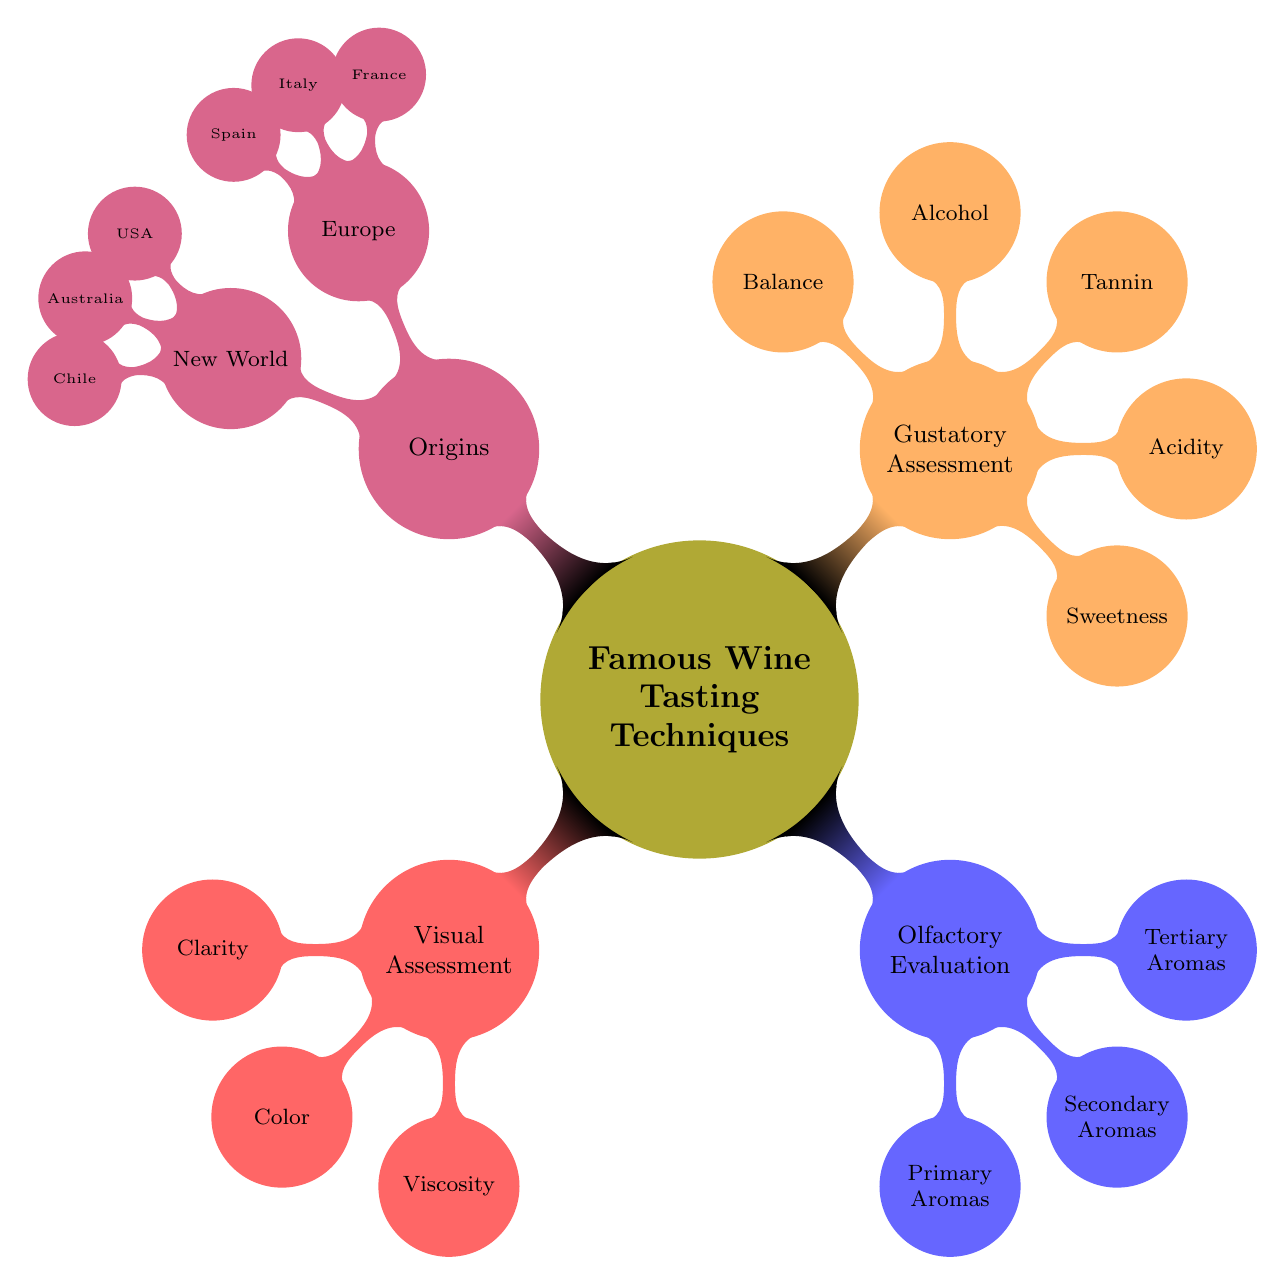What are the three main wine tasting techniques? The diagram identifies three primary wine tasting techniques: Visual Assessment, Olfactory Evaluation, and Gustatory Assessment. These are the main categories of wine tasting methods presented in the mind map.
Answer: Visual Assessment, Olfactory Evaluation, Gustatory Assessment How many aspects are included in Gustatory Assessment? The diagram lists five components under Gustatory Assessment: Sweetness, Acidity, Tannin, Alcohol, and Balance. Counting these elements provides the answer to the question regarding how many aspects are included.
Answer: 5 What types of aromas are included in Olfactory Evaluation? The Olfactory Evaluation section of the diagram specifies three types of aromas: Primary Aromas, Secondary Aromas, and Tertiary Aromas. By identifying these distinct categories, we can provide the answer.
Answer: Primary Aromas, Secondary Aromas, Tertiary Aromas Which country in Europe is associated with Bordeaux wine tasting techniques? The diagram lists France as one of the countries under the Origins in Europe section and specifically associates it with Bordeaux, indicating that France is known for this technique.
Answer: France What is the main focus of Visual Assessment? Visual Assessment focuses on three elements: Clarity, Color, and Viscosity. These aspects are essential for the visual evaluation of wine, helping tasters understand different properties visible in the wine.
Answer: Clarity, Color, Viscosity Which wine tasting technique relates to the relationship between acidity and freshness? The diagram shows that Acidity in the Gustatory Assessment section is specifically mentioned to contribute to the wine's freshness, highlighting the connection between these two concepts.
Answer: Acidity What is the primary aroma derived from light white wines? The diagram notes that Floral Aromas come from light white wines like Riesling, providing a direct answer regarding the specific aroma type associated with these wines.
Answer: Floral Aromas Which New World country is known for Shiraz tasting methods? According to the diagram, Australia is listed under New World, specifically mentioning Shiraz as a technique associated with its wine tasting practices. Therefore, Australia is the correct answer.
Answer: Australia Which two countries in Europe are known for their specific winemaking techniques? The diagram specifies Italy (for Chianti and Barolo) and Spain (for Tempranillo) as European countries known for distinct winemaking practices, providing a direct answer to the question.
Answer: Italy, Spain 